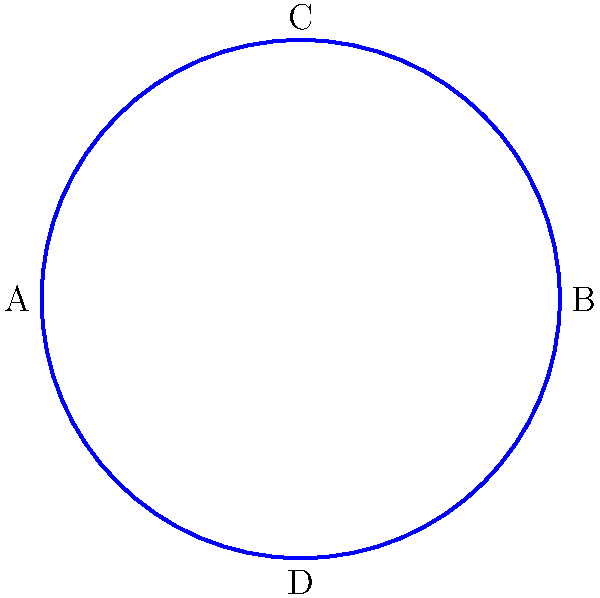In a controversial strangulation case, the ligature marks form a pattern similar to the knot shown above. The professor claims this is a simple overhand knot, but you suspect it's more complex. How many crossings does this knot actually have, and what implications might this have for the case? To determine the number of crossings in this knot, we need to carefully analyze the diagram:

1. Start at point A and follow the path clockwise.
2. Count each time the path crosses over or under itself.
3. We see one crossing between A and B.
4. Another crossing occurs between B and C.
5. A third crossing is visible between C and D.
6. The final crossing is between D and A.

In total, we count 4 crossings, not the 3 typically associated with a simple overhand knot.

Implications for the case:
1. The professor's claim of a simple overhand knot is incorrect, suggesting a potential oversight in the analysis.
2. A 4-crossing knot is more complex, possibly indicating a more deliberate or skilled perpetrator.
3. The additional complexity could imply a longer time to create the knot, potentially affecting the timeline of events.
4. The specific knot type (e.g., figure-eight knot) might provide clues about the perpetrator's background or training.
5. This discrepancy highlights the importance of accurate knot analysis in forensic investigations.
Answer: 4 crossings; implies more complex perpetrator and potential timeline discrepancies 